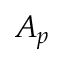<formula> <loc_0><loc_0><loc_500><loc_500>A _ { p }</formula> 